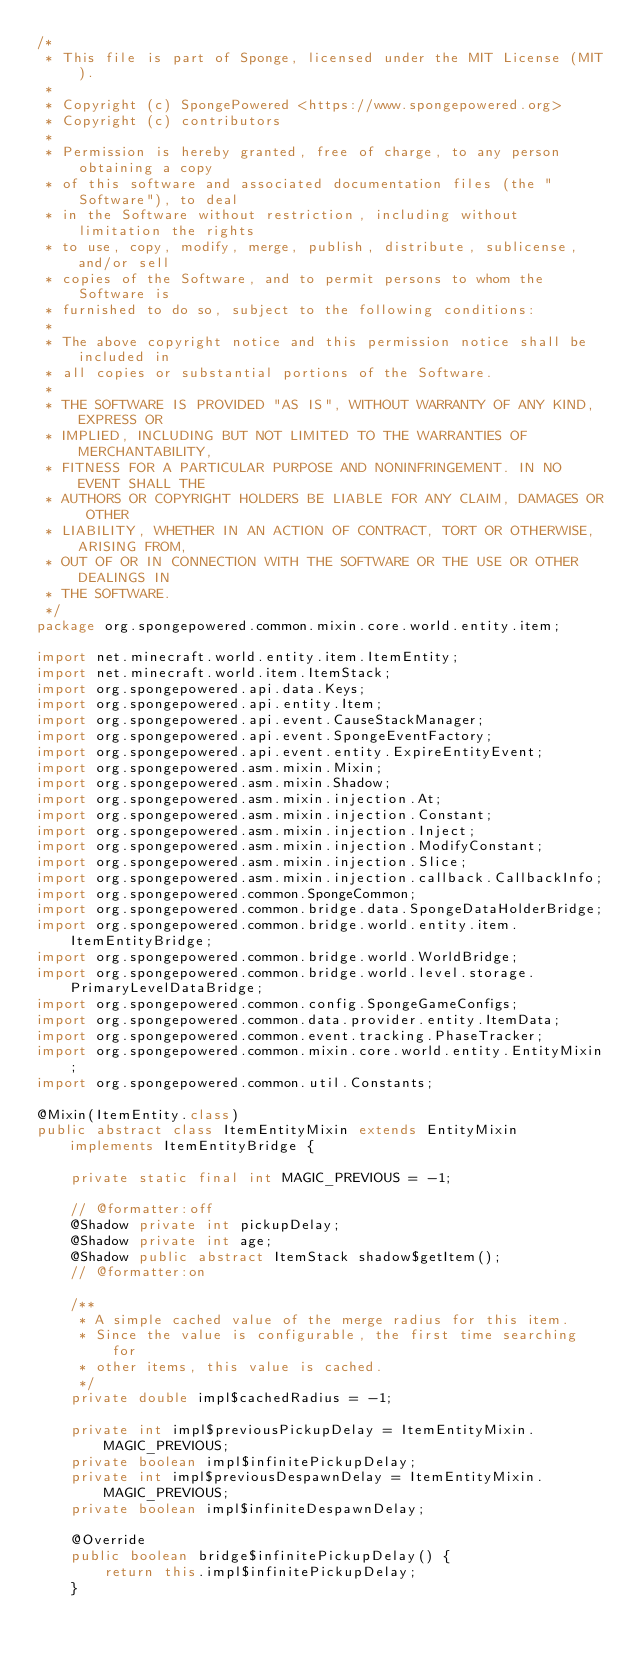<code> <loc_0><loc_0><loc_500><loc_500><_Java_>/*
 * This file is part of Sponge, licensed under the MIT License (MIT).
 *
 * Copyright (c) SpongePowered <https://www.spongepowered.org>
 * Copyright (c) contributors
 *
 * Permission is hereby granted, free of charge, to any person obtaining a copy
 * of this software and associated documentation files (the "Software"), to deal
 * in the Software without restriction, including without limitation the rights
 * to use, copy, modify, merge, publish, distribute, sublicense, and/or sell
 * copies of the Software, and to permit persons to whom the Software is
 * furnished to do so, subject to the following conditions:
 *
 * The above copyright notice and this permission notice shall be included in
 * all copies or substantial portions of the Software.
 *
 * THE SOFTWARE IS PROVIDED "AS IS", WITHOUT WARRANTY OF ANY KIND, EXPRESS OR
 * IMPLIED, INCLUDING BUT NOT LIMITED TO THE WARRANTIES OF MERCHANTABILITY,
 * FITNESS FOR A PARTICULAR PURPOSE AND NONINFRINGEMENT. IN NO EVENT SHALL THE
 * AUTHORS OR COPYRIGHT HOLDERS BE LIABLE FOR ANY CLAIM, DAMAGES OR OTHER
 * LIABILITY, WHETHER IN AN ACTION OF CONTRACT, TORT OR OTHERWISE, ARISING FROM,
 * OUT OF OR IN CONNECTION WITH THE SOFTWARE OR THE USE OR OTHER DEALINGS IN
 * THE SOFTWARE.
 */
package org.spongepowered.common.mixin.core.world.entity.item;

import net.minecraft.world.entity.item.ItemEntity;
import net.minecraft.world.item.ItemStack;
import org.spongepowered.api.data.Keys;
import org.spongepowered.api.entity.Item;
import org.spongepowered.api.event.CauseStackManager;
import org.spongepowered.api.event.SpongeEventFactory;
import org.spongepowered.api.event.entity.ExpireEntityEvent;
import org.spongepowered.asm.mixin.Mixin;
import org.spongepowered.asm.mixin.Shadow;
import org.spongepowered.asm.mixin.injection.At;
import org.spongepowered.asm.mixin.injection.Constant;
import org.spongepowered.asm.mixin.injection.Inject;
import org.spongepowered.asm.mixin.injection.ModifyConstant;
import org.spongepowered.asm.mixin.injection.Slice;
import org.spongepowered.asm.mixin.injection.callback.CallbackInfo;
import org.spongepowered.common.SpongeCommon;
import org.spongepowered.common.bridge.data.SpongeDataHolderBridge;
import org.spongepowered.common.bridge.world.entity.item.ItemEntityBridge;
import org.spongepowered.common.bridge.world.WorldBridge;
import org.spongepowered.common.bridge.world.level.storage.PrimaryLevelDataBridge;
import org.spongepowered.common.config.SpongeGameConfigs;
import org.spongepowered.common.data.provider.entity.ItemData;
import org.spongepowered.common.event.tracking.PhaseTracker;
import org.spongepowered.common.mixin.core.world.entity.EntityMixin;
import org.spongepowered.common.util.Constants;

@Mixin(ItemEntity.class)
public abstract class ItemEntityMixin extends EntityMixin implements ItemEntityBridge {

    private static final int MAGIC_PREVIOUS = -1;

    // @formatter:off
    @Shadow private int pickupDelay;
    @Shadow private int age;
    @Shadow public abstract ItemStack shadow$getItem();
    // @formatter:on

    /**
     * A simple cached value of the merge radius for this item.
     * Since the value is configurable, the first time searching for
     * other items, this value is cached.
     */
    private double impl$cachedRadius = -1;

    private int impl$previousPickupDelay = ItemEntityMixin.MAGIC_PREVIOUS;
    private boolean impl$infinitePickupDelay;
    private int impl$previousDespawnDelay = ItemEntityMixin.MAGIC_PREVIOUS;
    private boolean impl$infiniteDespawnDelay;

    @Override
    public boolean bridge$infinitePickupDelay() {
        return this.impl$infinitePickupDelay;
    }
</code> 